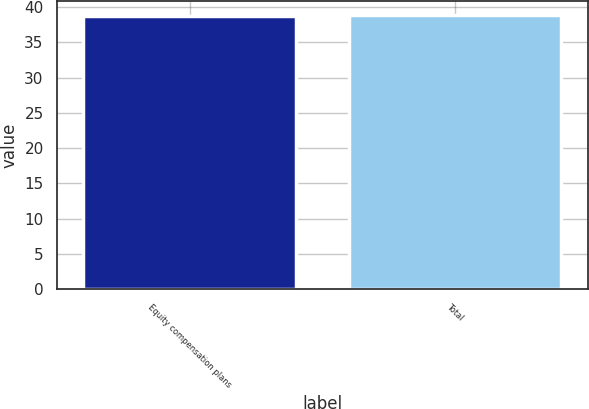<chart> <loc_0><loc_0><loc_500><loc_500><bar_chart><fcel>Equity compensation plans<fcel>Total<nl><fcel>38.77<fcel>38.87<nl></chart> 